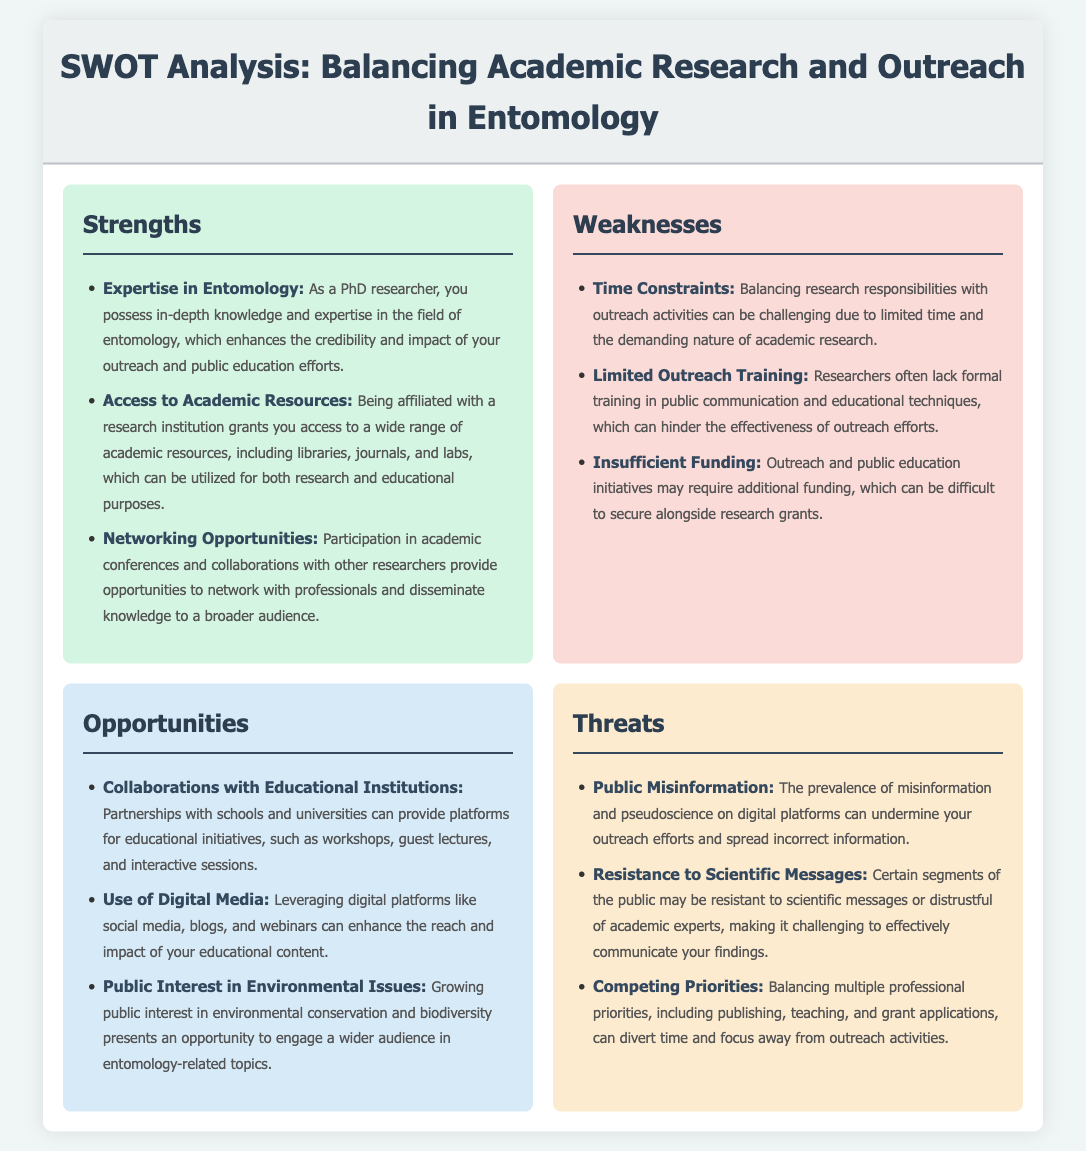What are the strengths listed? The strengths section lists three specific aspects related to academic research and outreach efforts in entomology.
Answer: Expertise in Entomology, Access to Academic Resources, Networking Opportunities What is a weakness related to time? The weakness identified highlights a specific challenge faced when trying to manage multiple responsibilities.
Answer: Time Constraints What is an opportunity involving digital media? This opportunity emphasizes the use of modern platforms to enhance outreach efforts in entomology.
Answer: Use of Digital Media What is a threat related to public perception? This threat addresses a major challenge faced in the field regarding communication and public understanding.
Answer: Resistance to Scientific Messages How many weaknesses are mentioned? The weaknesses section contains a specific count of the listed challenges.
Answer: Three What does the strengths section enhance? This question asks about the overall impact or significance of the strengths identified in the document.
Answer: Credibility and impact What is a potential collaboration mentioned in the opportunities section? This question seeks a specific type of partnership that can aid educational initiatives.
Answer: Collaborations with Educational Institutions What is described as a growing public interest? The document mentions a specific trend that can be leveraged for outreach purposes.
Answer: Environmental Issues 